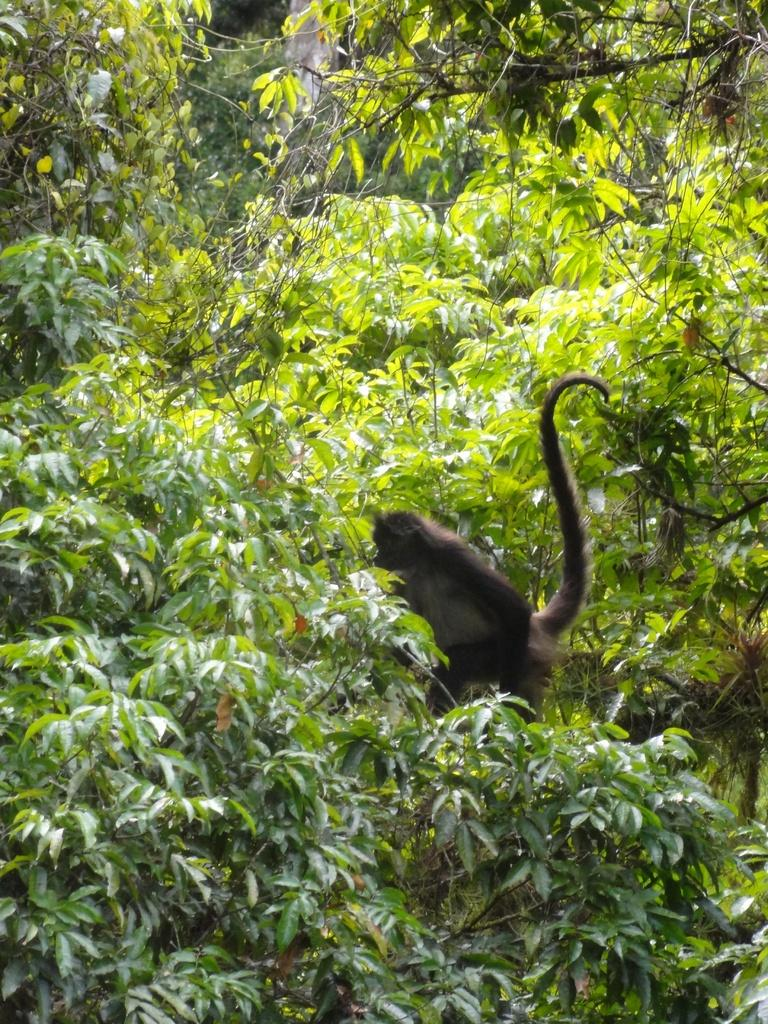What animal is the main subject of the image? There is a monkey in the image. Where is the monkey located in the image? The monkey is in the middle of the image. What can be seen in the background of the image? There are trees in the background of the image. What type of pencil does the monkey use to draw in the image? There is no pencil present in the image, and the monkey is not shown drawing. 